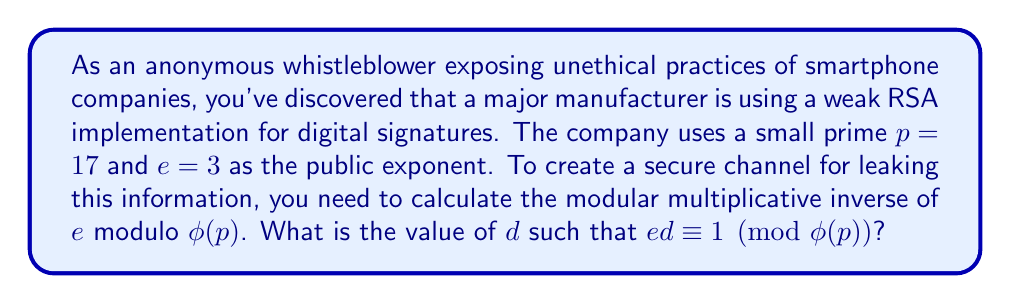Can you solve this math problem? To find the modular multiplicative inverse of $e$ modulo $\phi(p)$, we need to follow these steps:

1) First, calculate $\phi(p)$:
   Since $p = 17$ is prime, $\phi(p) = p - 1 = 16$

2) We need to find $d$ such that $ed \equiv 1 \pmod{16}$
   Or equivalently, $3d \equiv 1 \pmod{16}$

3) We can use the extended Euclidean algorithm to find $d$:

   $16 = 5 \cdot 3 + 1$
   $3 = 3 \cdot 1 + 0$

   Working backwards:
   $1 = 16 - 5 \cdot 3$
   $1 = 16 + (-5) \cdot 3$

4) Therefore, $-5$ is a solution for $d$. However, we need a positive number less than $\phi(p) = 16$.

5) We can add $\phi(p)$ to $-5$ to get an equivalent solution:
   $-5 + 16 = 11$

6) Verify: $3 \cdot 11 = 33 \equiv 1 \pmod{16}$

Thus, $d = 11$ is the modular multiplicative inverse of $e = 3$ modulo $\phi(p) = 16$.
Answer: $d = 11$ 